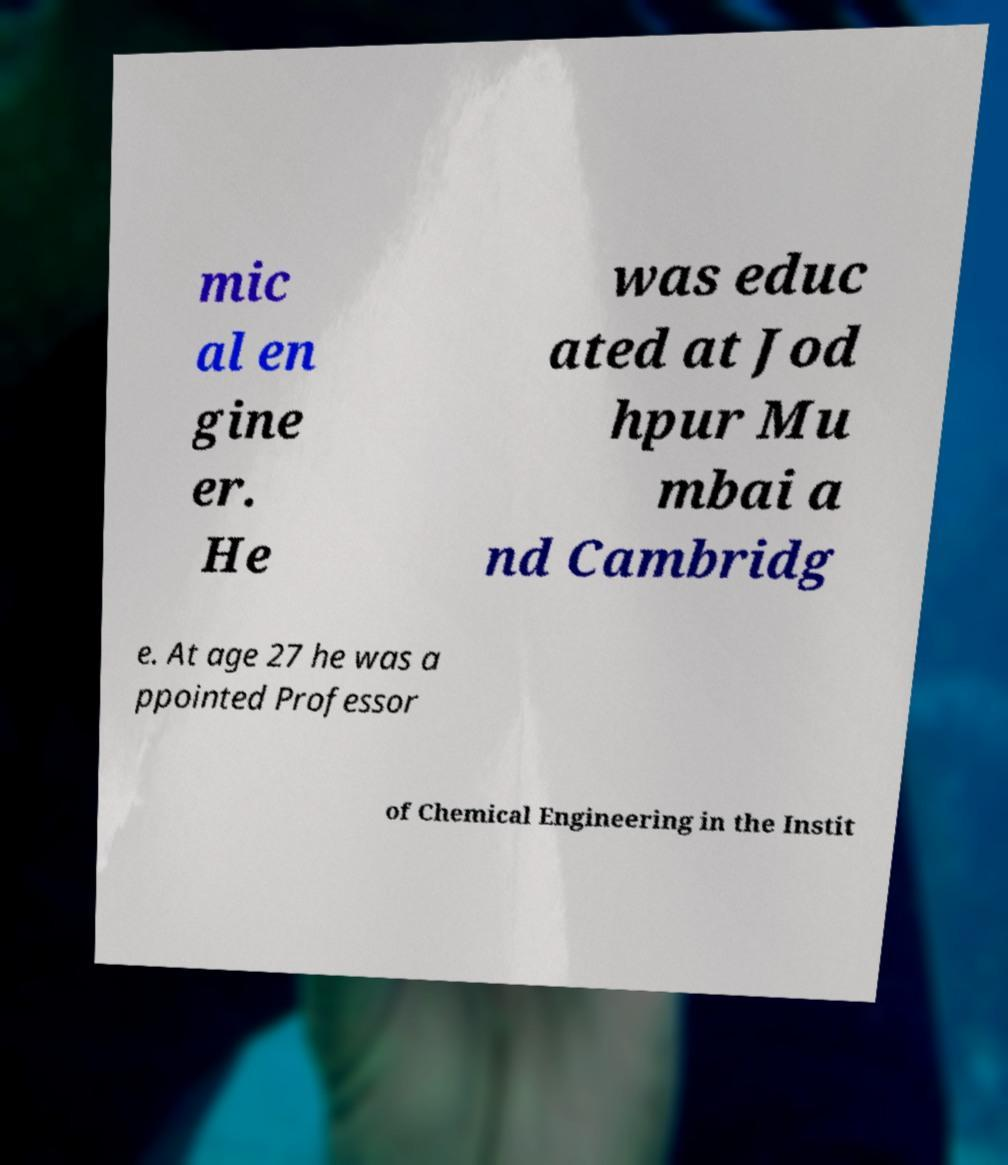Please identify and transcribe the text found in this image. mic al en gine er. He was educ ated at Jod hpur Mu mbai a nd Cambridg e. At age 27 he was a ppointed Professor of Chemical Engineering in the Instit 